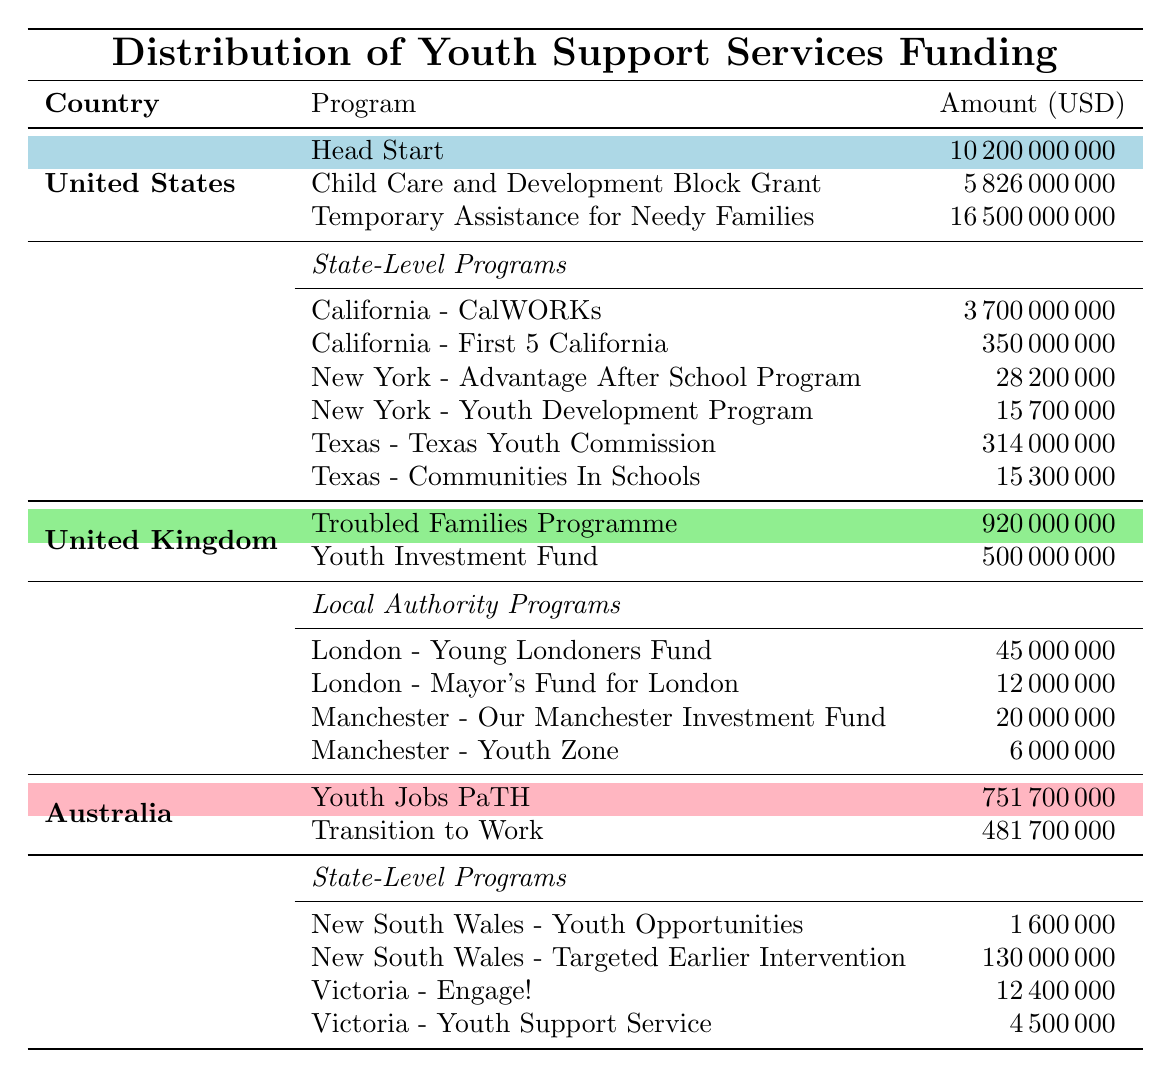What is the total funding for Federal Programs in the United States? To find the total funding for Federal Programs, we add the amounts: Head Start (10,200,000,000) + Child Care and Development Block Grant (5,826,000,000) + Temporary Assistance for Needy Families (16,500,000,000). The sum is 10,200,000,000 + 5,826,000,000 + 16,500,000,000 = 32,526,000,000.
Answer: 32,526,000,000 Which program in the UK has the highest funding? Looking at the National Programs in the UK, Troubled Families Programme has 920,000,000, while Youth Investment Fund has 500,000,000. Therefore, Troubled Families Programme has the highest funding at 920,000,000.
Answer: Troubled Families Programme What is the funding amount for Youth Support Service in Australia? The Youth Support Service in Australia has a funding amount of 4,500,000, according to the State-Level Programs for Victoria.
Answer: 4,500,000 Which country has the highest total funding for youth support services? We need to calculate the total funding for each country. United States: 32,526,000,000; United Kingdom: 1,420,000,000 (920,000,000 + 500,000,000 + 450,00000 + 12000000 + 20000000 + 6000000); Australia: 1,233,700,000 (751,700,000 + 481,700,000 + 1,600,000 + 130,000,000 + 12,400,000 + 4,500,000). The highest is the United States with 32,526,000,000.
Answer: United States How much more funding does the California CalWORKs program receive compared to the New York Advantage After School Program? The funding for California CalWORKs is 3,700,000,000 and for New York Advantage After School Program is 28,200,000. The difference is 3,700,000,000 - 28,200,000 = 3,671,800,000.
Answer: 3,671,800,000 Is the funding for the Youth Jobs PaTH program in Australia higher than both programs in California? The Youth Jobs PaTH program in Australia has funding of 751,700,000. The programs in California are CalWORKs at 3,700,000,000 and First 5 California at 350,000,000. Since 751,700,000 is not higher than 3,700,000,000 and 350,000,000, the answer is no.
Answer: No What is the average funding amount of state-level programs in the United States? To find the average, we consider the state-level programs' funding amounts: California-CalWORKs (3,700,000,000), California-First 5 California (350,000,000), New York-Advantage After School Program (28,200,000), New York-Youth Development Program (15,700,000), Texas-Texas Youth Commission (314,000,000), and Texas-Communities In Schools (15,300,000). The total is 3,700,000,000 + 350,000,000 + 28,200,000 + 15,700,000 + 314,000,000 + 15,300,000 = 4,423,200,000. There are 6 programs so the average is 4,423,200,000 / 6 = 737,200,000.
Answer: 737,200,000 Which region in the UK has the lowest funding for youth support services? We compare the local authority programs: London - Young Londoners Fund (45,000,000), London - Mayor's Fund for London (12,000,000), Manchester - Our Manchester Investment Fund (20,000,000), and Manchester - Youth Zone (6,000,000). The lowest is Manchester - Youth Zone with 6,000,000.
Answer: Manchester - Youth Zone What is the total funding for State-Level Programs in Australia? The State-Level Programs in Australia have the following funding amounts: New South Wales - Youth Opportunities (1,600,000), New South Wales - Targeted Earlier Intervention (130,000,000), Victoria - Engage! (12,400,000), and Victoria - Youth Support Service (4,500,000). The total is 1,600,000 + 130,000,000 + 12,400,000 + 4,500,000 = 148,500,000.
Answer: 148,500,000 Does the Temporary Assistance for Needy Families funding exceed that of the Youth Investment Fund in the UK? The funding for Temporary Assistance for Needy Families is 16,500,000,000 and for Youth Investment Fund is 500,000,000. Since 16,500,000,000 is greater than 500,000,000, the answer is yes.
Answer: Yes 